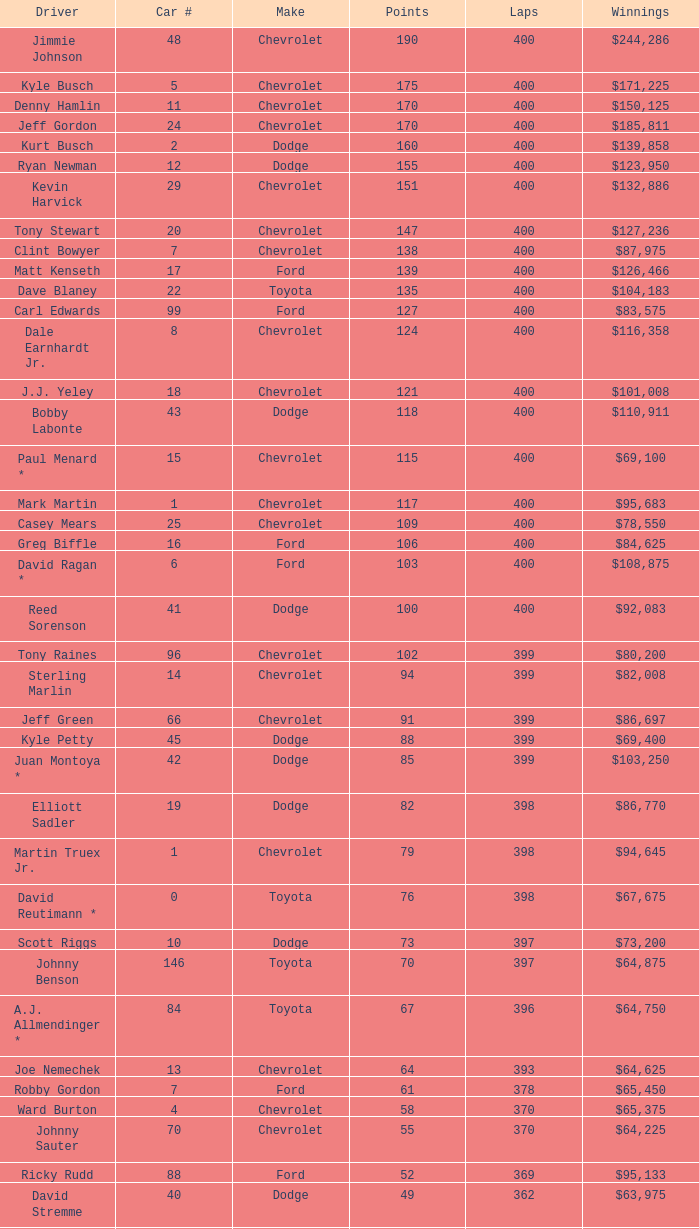With more than 49 points, what is the car number of a dodge that has not yet completed 369 laps? None. 